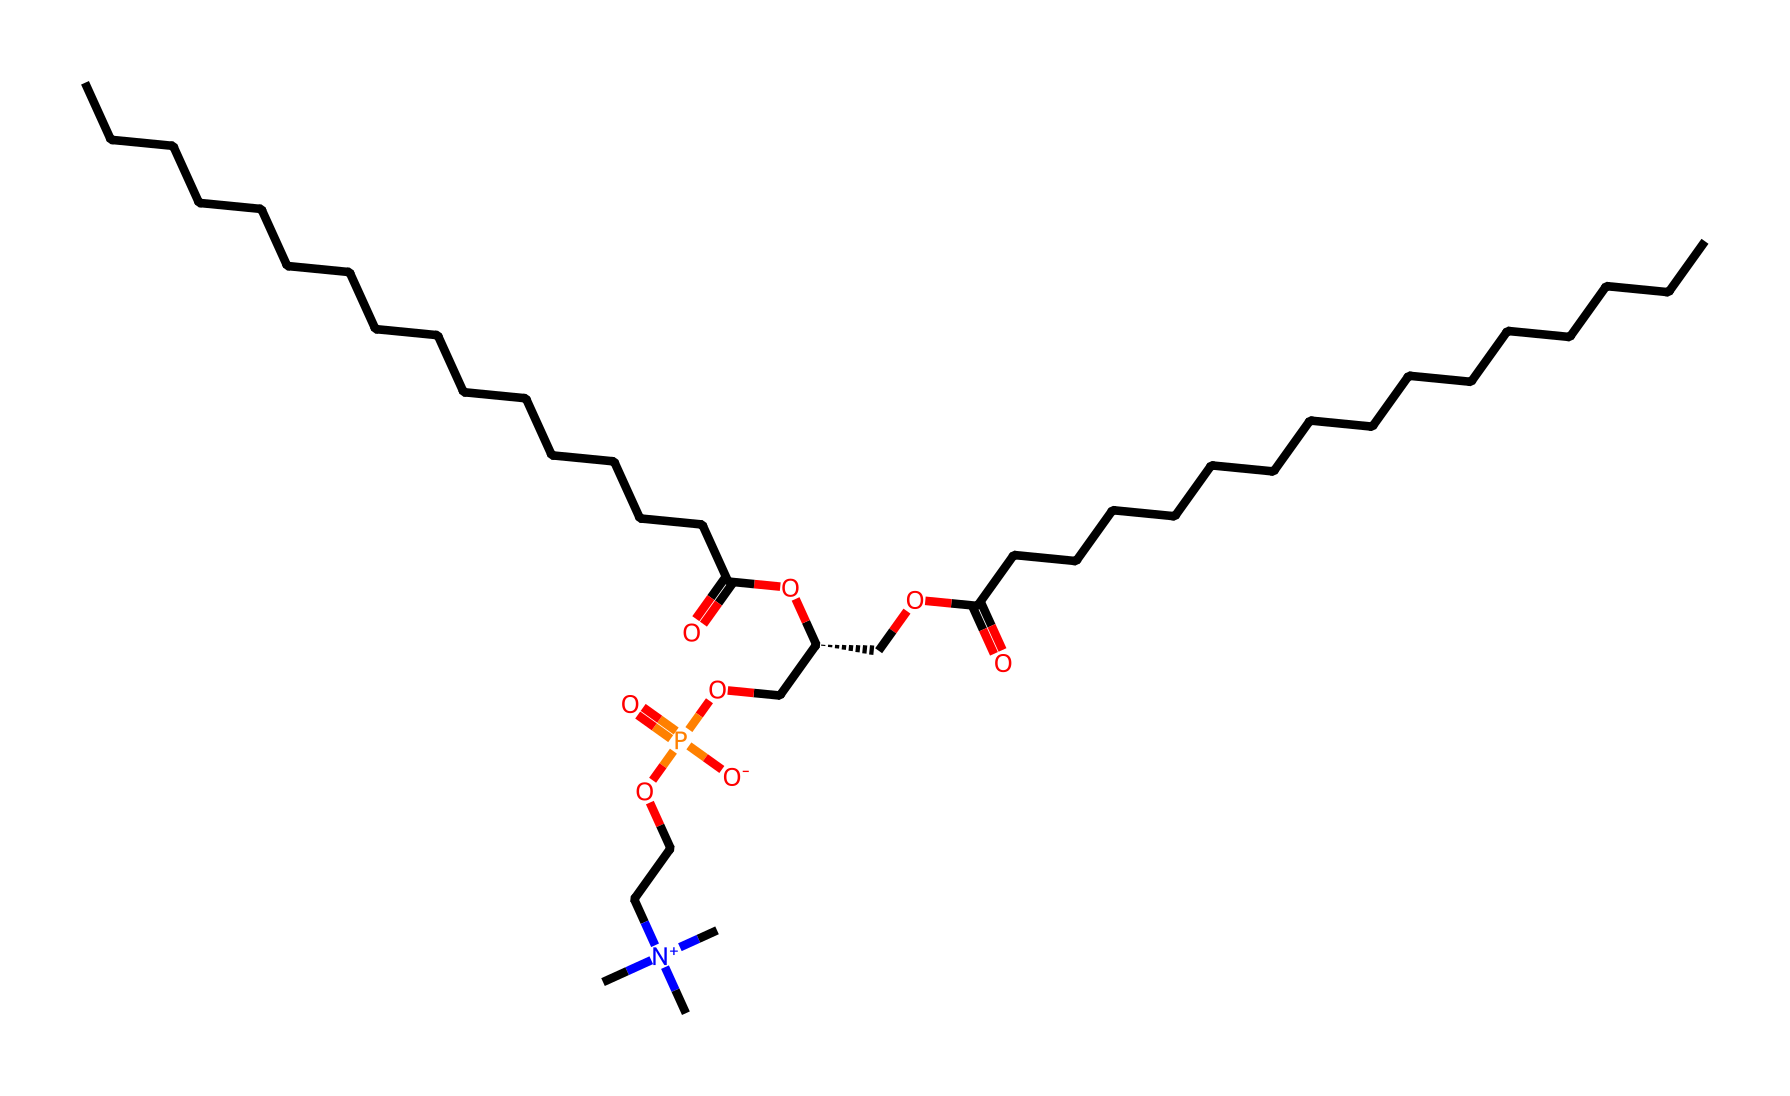What is the molecular formula of phosphatidylcholine? The molecular formula can be derived from the SMILES representation by counting the carbon (C), hydrogen (H), nitrogen (N), phosphorus (P), and oxygen (O) atoms present. The formula is C22H48N1O8P.
Answer: C22H48N1O8P How many phosphate groups are present in this structure? By examining the structure, we can identify the phosphate group represented by the P atom connected to four oxygen atoms. There is one phosphate group in this phospholipid.
Answer: 1 Which atom in this chemical is responsible for its classification as a phospholipid? The presence of the phosphate group (P) among the molecular structure identifies it as a phospholipid. Phospholipids have distinctive phosphate groups, which are essential for their biological function.
Answer: phosphate What functional groups are indicated in the chemical structure? The SMILES notation includes ester groups (-O-C=O) and an amine derivative (N+), which signify the functional groups in phosphatidylcholine. These groups are typical of phospholipids.
Answer: ester and quaternary amine How many carbon atoms are contained in the fatty acid chains of this compound? Observing the structure, two long carbon chains can be identified on either side of the molecule. Each chain consists of 12 carbon atoms, contributing a total of 24 carbon atoms from the fatty acid portions. The detailed structure indicates that 22 carbon atoms are confirmed overall when considering the full molecule.
Answer: 22 What is the significance of the nitrogen atom in this chemical structure? The nitrogen atom is part of a quaternary amine that contributes to the hydrophilic properties of phosphatidylcholine, enabling it to interact with both lipid and aqueous environments. This duality is crucial for the formation of cell membranes.
Answer: hydrophilic properties How many oxygen atoms are present in this molecule? The structure reveals the presence of eight oxygen atoms, which contribute to the functional groups and overall structure of the phospholipid. Each oxygen is associated with various groups like esters and phosphates.
Answer: 8 